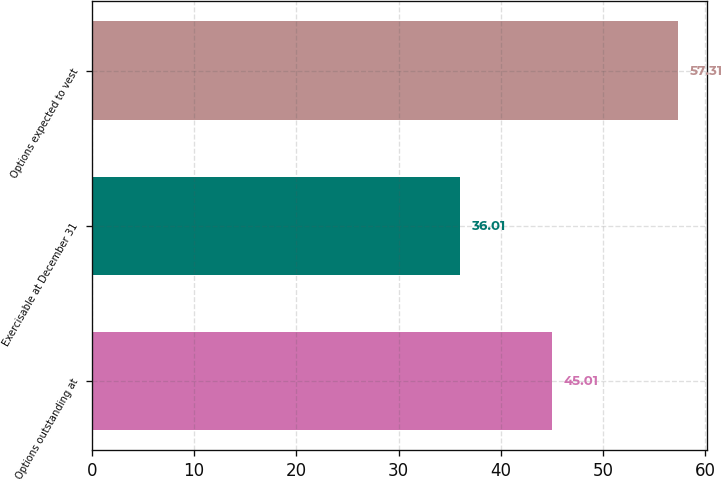Convert chart to OTSL. <chart><loc_0><loc_0><loc_500><loc_500><bar_chart><fcel>Options outstanding at<fcel>Exercisable at December 31<fcel>Options expected to vest<nl><fcel>45.01<fcel>36.01<fcel>57.31<nl></chart> 